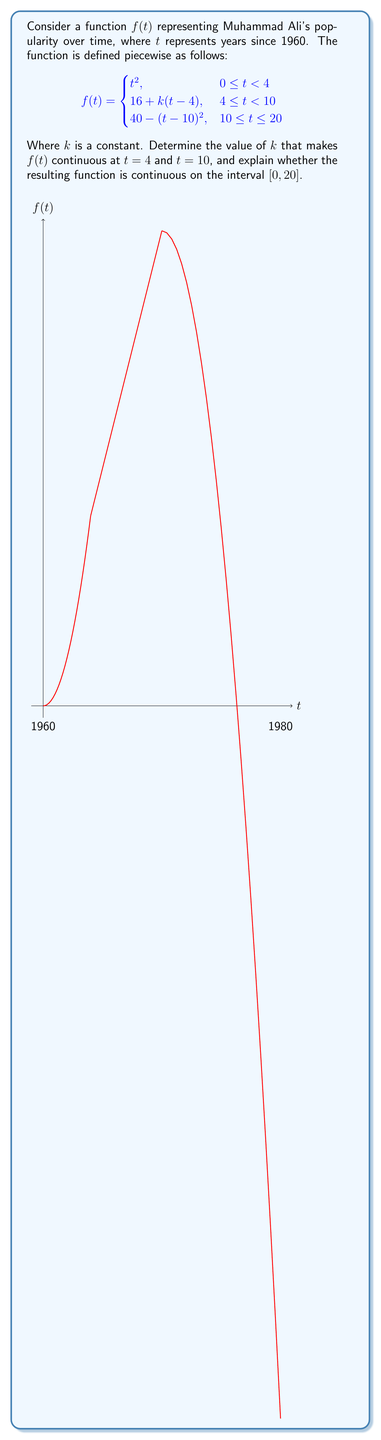Solve this math problem. To determine the continuity of $f(t)$, we need to check for continuity at the transition points $t = 4$ and $t = 10$, and ensure the function is continuous within each piece.

1) For continuity at $t = 4$:
   Left limit: $\lim_{t \to 4^-} f(t) = 4^2 = 16$
   Right limit: $\lim_{t \to 4^+} f(t) = 16 + k(4-4) = 16$
   These limits are equal, so we just need $f(4) = 16$ for continuity at $t = 4$.

2) For continuity at $t = 10$:
   Left limit: $\lim_{t \to 10^-} f(t) = 16 + k(10-4) = 16 + 6k$
   Right limit: $\lim_{t \to 10^+} f(t) = 40 - (10-10)^2 = 40$
   For continuity, we need these to be equal:
   $16 + 6k = 40$
   $6k = 24$
   $k = 4$

3) Checking continuity within each piece:
   - $t^2$ is continuous for $0 \leq t < 4$
   - $16 + 4(t-4)$ is continuous for $4 \leq t < 10$
   - $40 - (t-10)^2$ is continuous for $10 \leq t \leq 20$

4) Checking continuity at $t = 4$ with $k = 4$:
   $f(4) = 4^2 = 16$, which matches the limit from both sides.

5) Checking continuity at $t = 10$ with $k = 4$:
   Left limit: $16 + 4(10-4) = 40$
   Right limit: $40 - (10-10)^2 = 40$
   $f(10) = 40$

Therefore, with $k = 4$, the function is continuous at both transition points and within each piece, making it continuous on the entire interval $[0, 20]$.
Answer: $k = 4$; $f(t)$ is continuous on $[0, 20]$. 